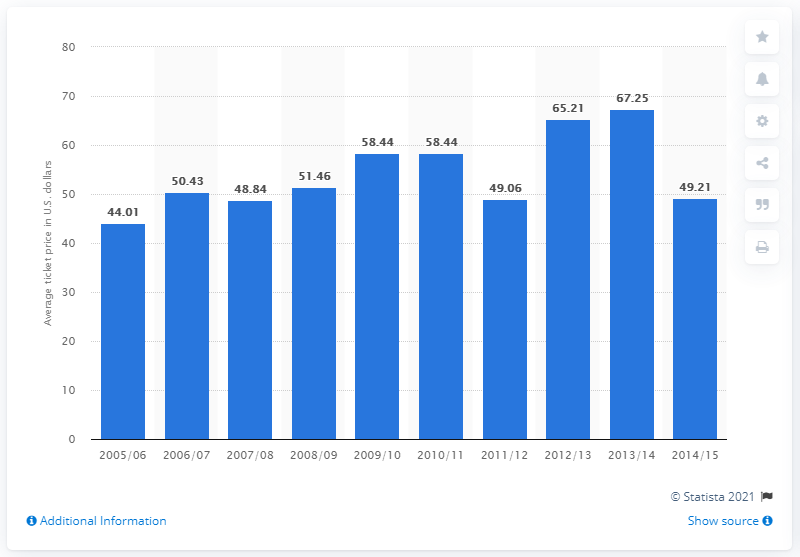Specify some key components in this picture. In the year 2005/2006, the ticket price for New York Islanders games was significantly low. In the 2005/2006 season, the average ticket price was 44.01 dollars. The ticket price for New York Islanders games was particularly high in the 2013/2014 season. 